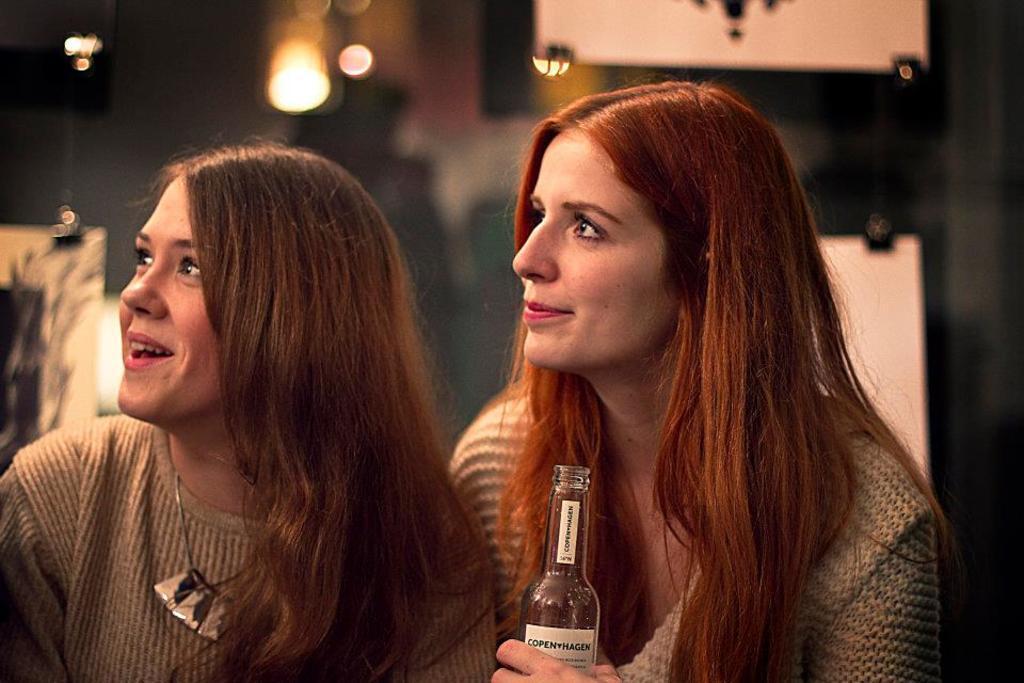In one or two sentences, can you explain what this image depicts? In this image there are two women smiling and looking to the left side of the image, one of them is holding a bottle. The background is blurry. 